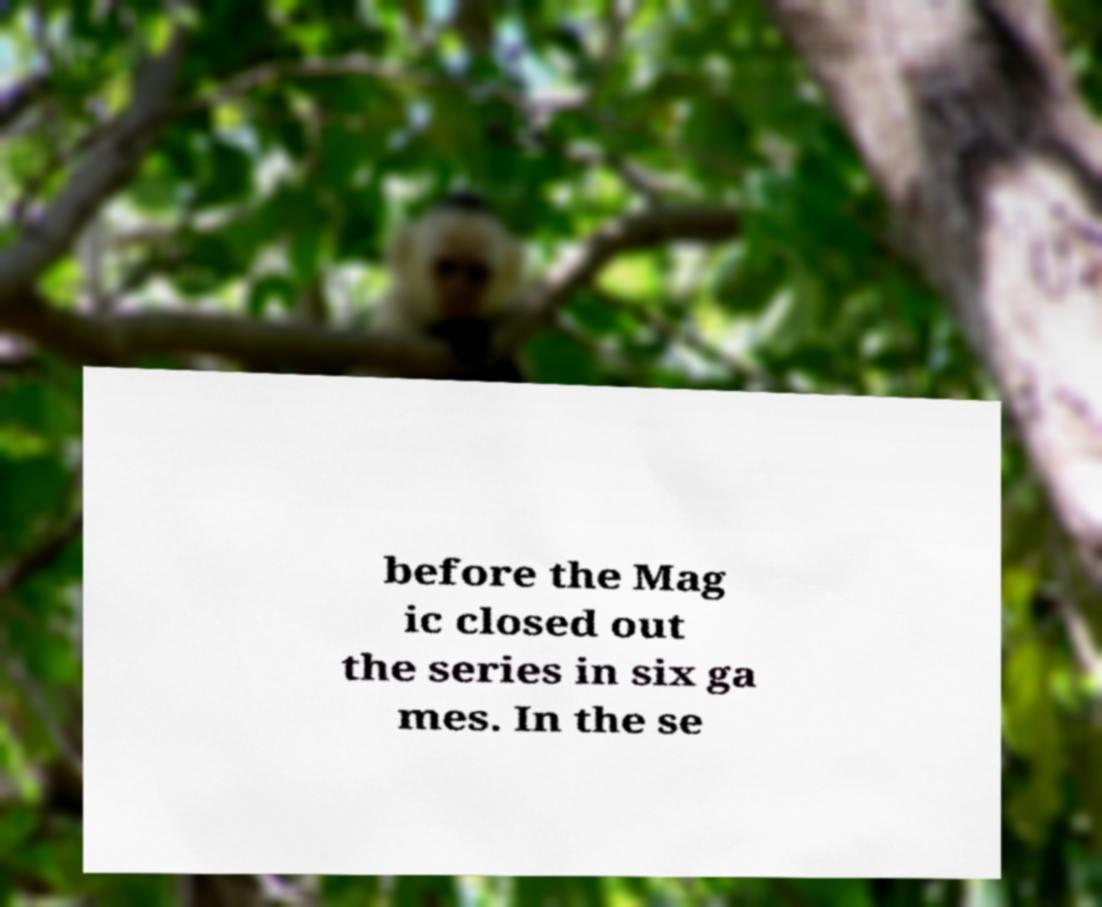Could you extract and type out the text from this image? before the Mag ic closed out the series in six ga mes. In the se 